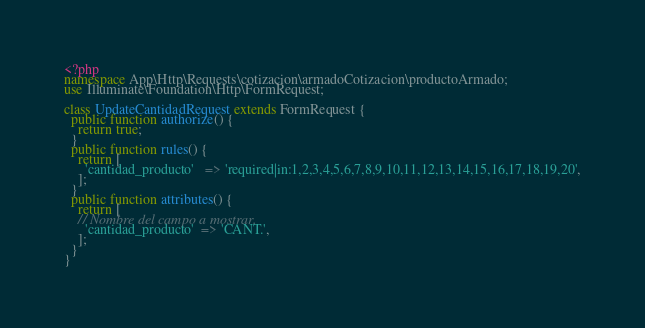<code> <loc_0><loc_0><loc_500><loc_500><_PHP_><?php
namespace App\Http\Requests\cotizacion\armadoCotizacion\productoArmado;
use Illuminate\Foundation\Http\FormRequest;

class UpdateCantidadRequest extends FormRequest {
  public function authorize() {
    return true;
  }
  public function rules() {
    return [
      'cantidad_producto'   => 'required|in:1,2,3,4,5,6,7,8,9,10,11,12,13,14,15,16,17,18,19,20',
    ];
  }
  public function attributes() {
    return [
    // Nombre del campo a mostrar.
      'cantidad_producto'  => 'CANT.',
    ];
  }
}</code> 